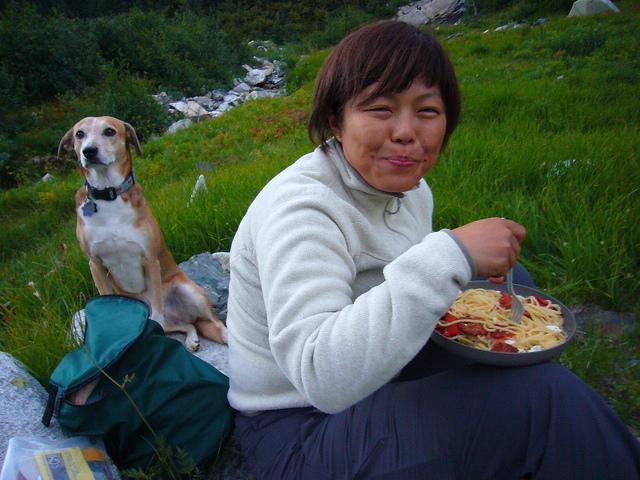How many handbags are visible?
Give a very brief answer. 1. 